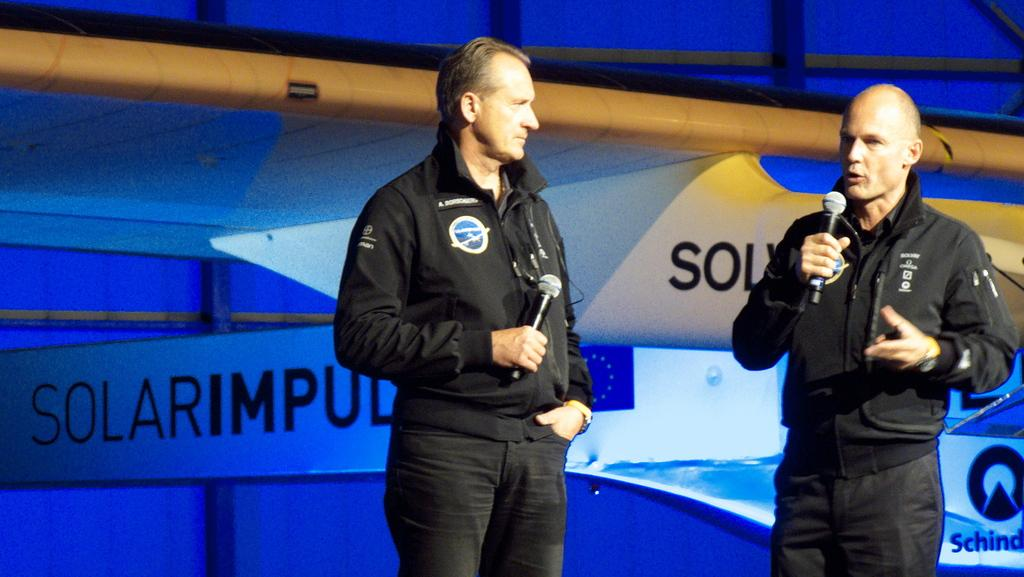What are the two people in the image holding? The two people in the image are holding microphones. What can be seen on the boards in the image? There are boards with text in the image. What is visible in the background of the image? There is a wall visible in the background of the image. What shape is the verse taking in the image? There is no verse present in the image, so it cannot be determined what shape it might take. 